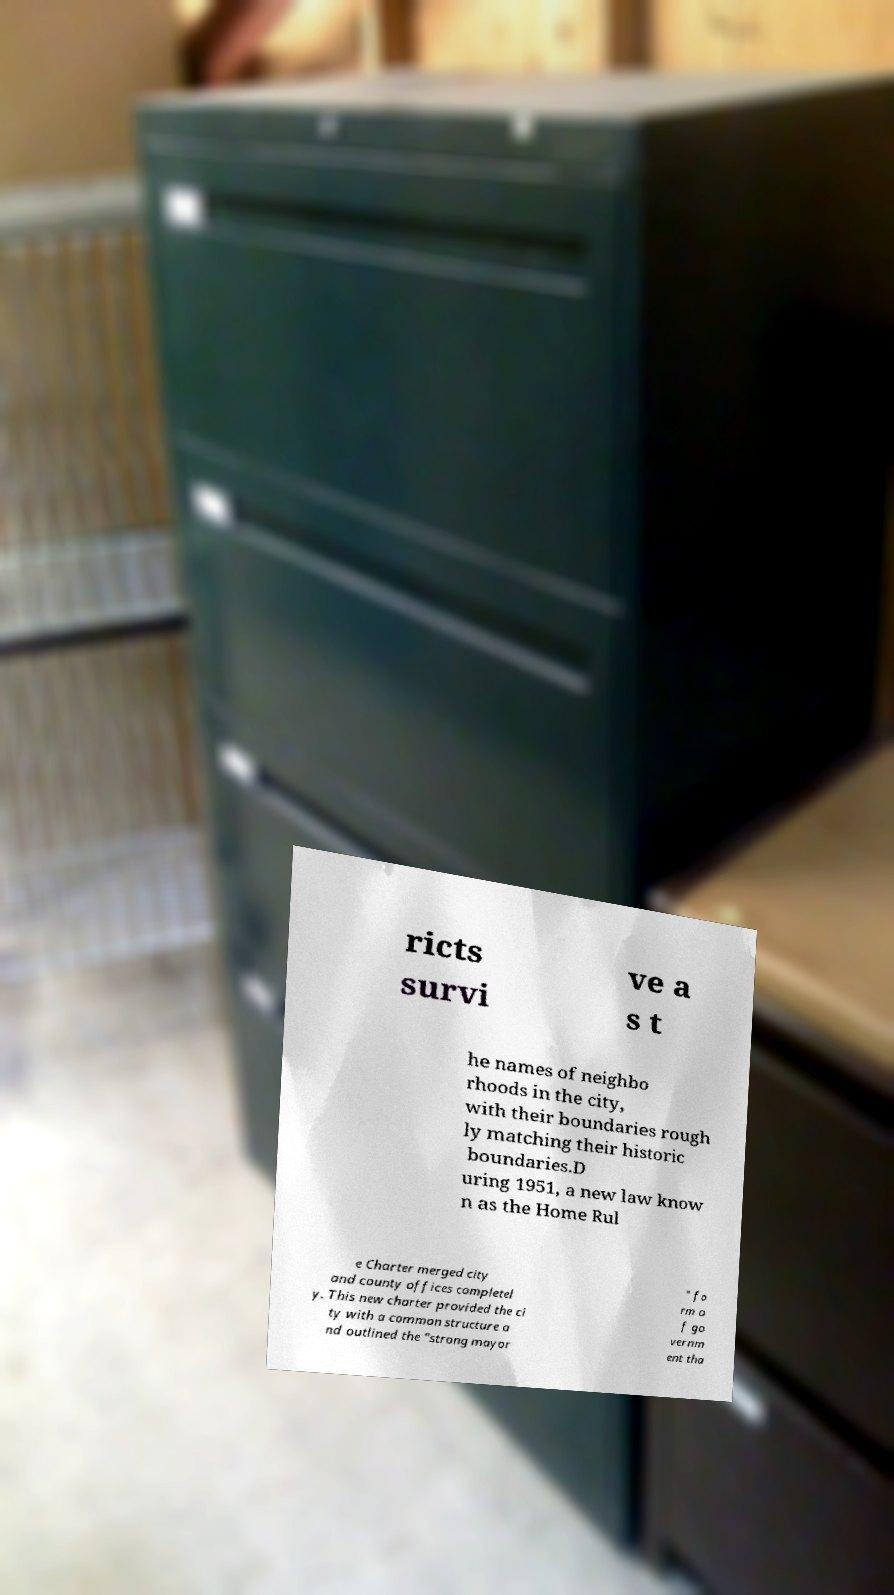What messages or text are displayed in this image? I need them in a readable, typed format. ricts survi ve a s t he names of neighbo rhoods in the city, with their boundaries rough ly matching their historic boundaries.D uring 1951, a new law know n as the Home Rul e Charter merged city and county offices completel y. This new charter provided the ci ty with a common structure a nd outlined the "strong mayor " fo rm o f go vernm ent tha 